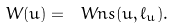Convert formula to latex. <formula><loc_0><loc_0><loc_500><loc_500>W ( u ) = \ W n s ( u , \ell _ { u } ) .</formula> 